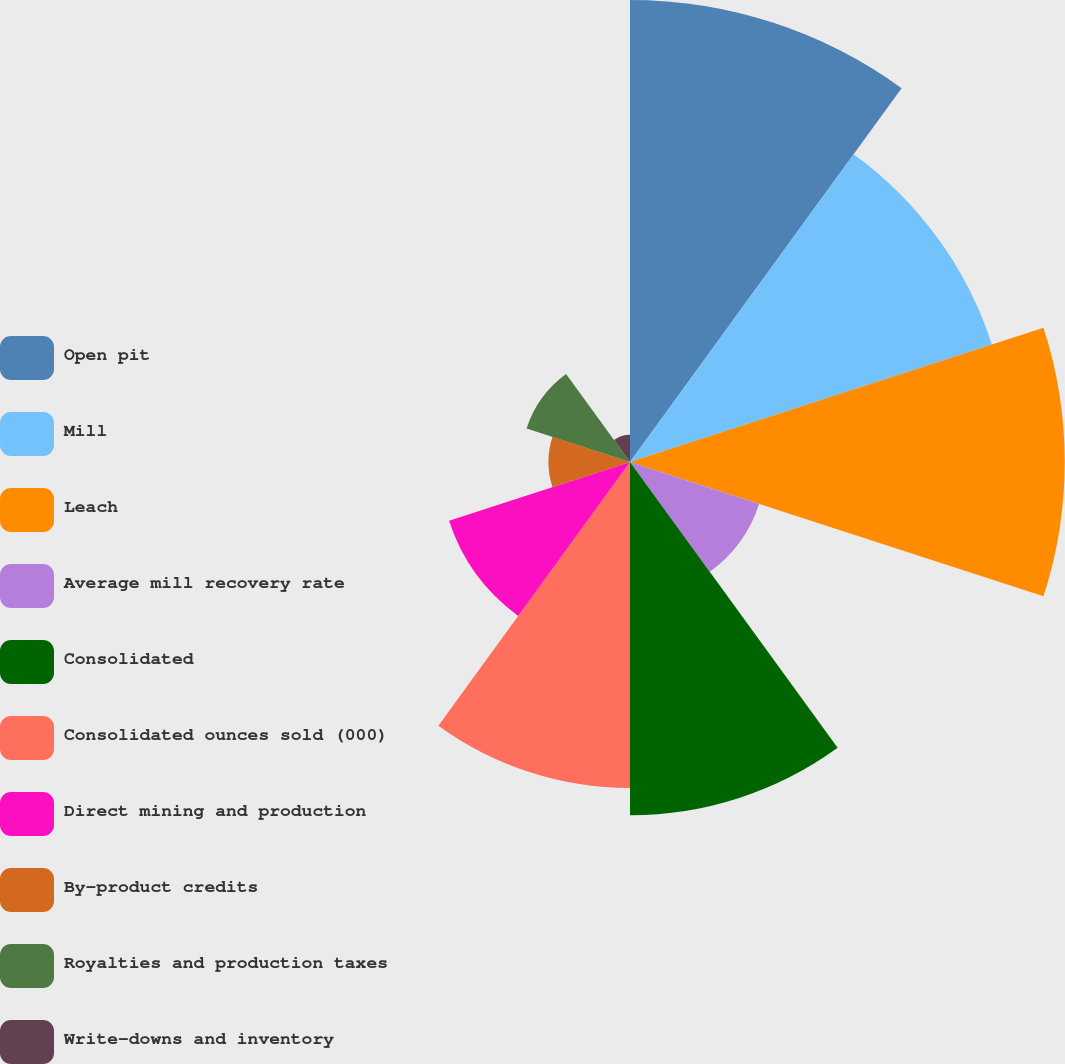Convert chart to OTSL. <chart><loc_0><loc_0><loc_500><loc_500><pie_chart><fcel>Open pit<fcel>Mill<fcel>Leach<fcel>Average mill recovery rate<fcel>Consolidated<fcel>Consolidated ounces sold (000)<fcel>Direct mining and production<fcel>By-product credits<fcel>Royalties and production taxes<fcel>Write-downs and inventory<nl><fcel>18.48%<fcel>15.22%<fcel>17.39%<fcel>5.43%<fcel>14.13%<fcel>13.04%<fcel>7.61%<fcel>3.26%<fcel>4.35%<fcel>1.09%<nl></chart> 